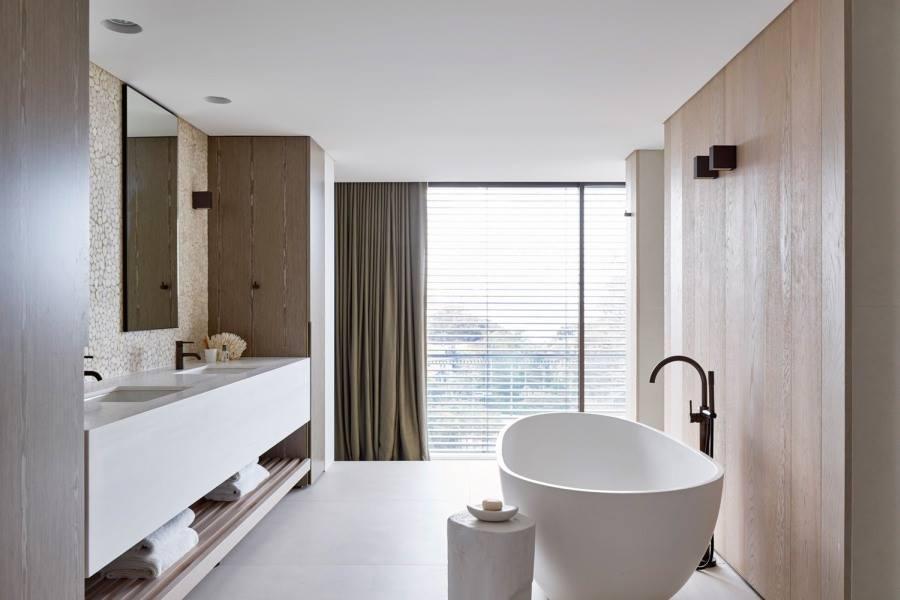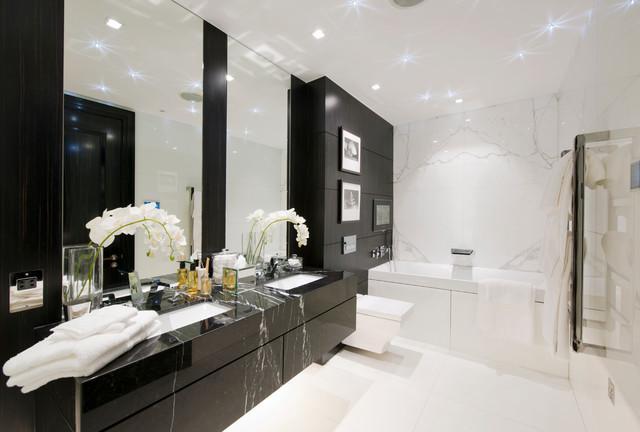The first image is the image on the left, the second image is the image on the right. Examine the images to the left and right. Is the description "One of the sinks is mostly wood paneled." accurate? Answer yes or no. No. 